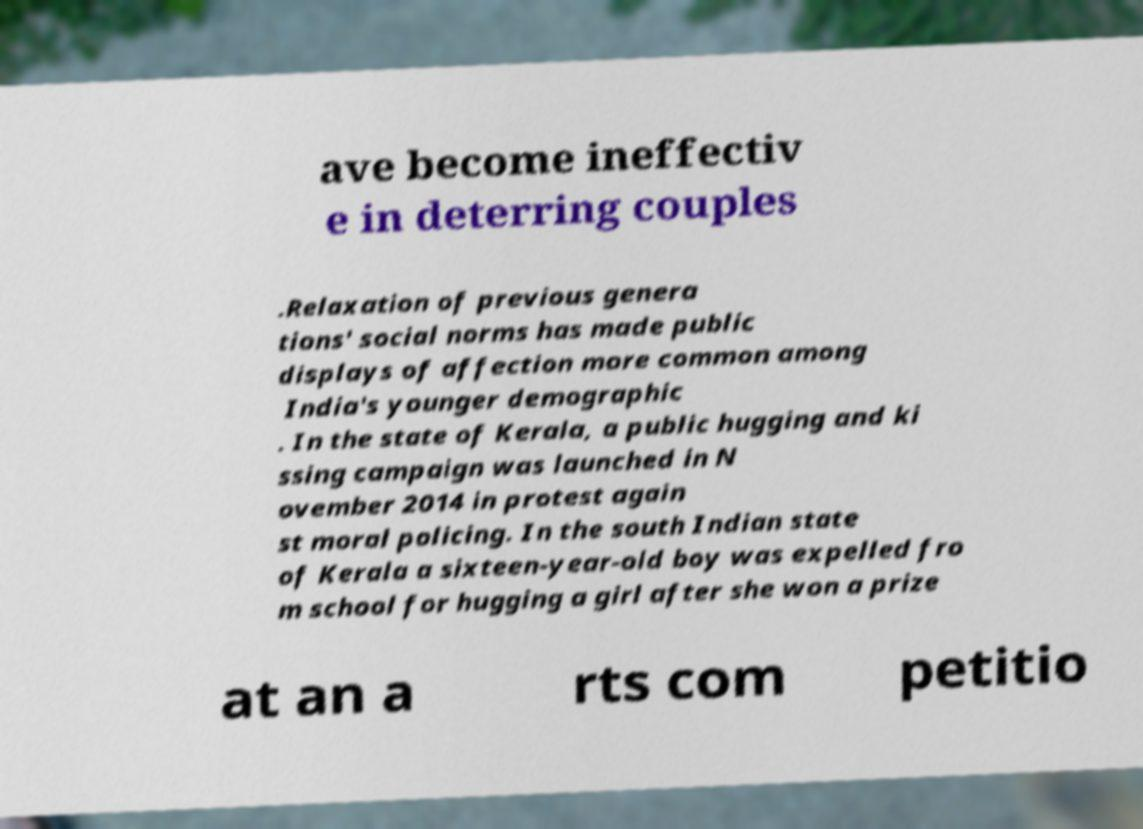Please identify and transcribe the text found in this image. ave become ineffectiv e in deterring couples .Relaxation of previous genera tions' social norms has made public displays of affection more common among India's younger demographic . In the state of Kerala, a public hugging and ki ssing campaign was launched in N ovember 2014 in protest again st moral policing. In the south Indian state of Kerala a sixteen-year-old boy was expelled fro m school for hugging a girl after she won a prize at an a rts com petitio 